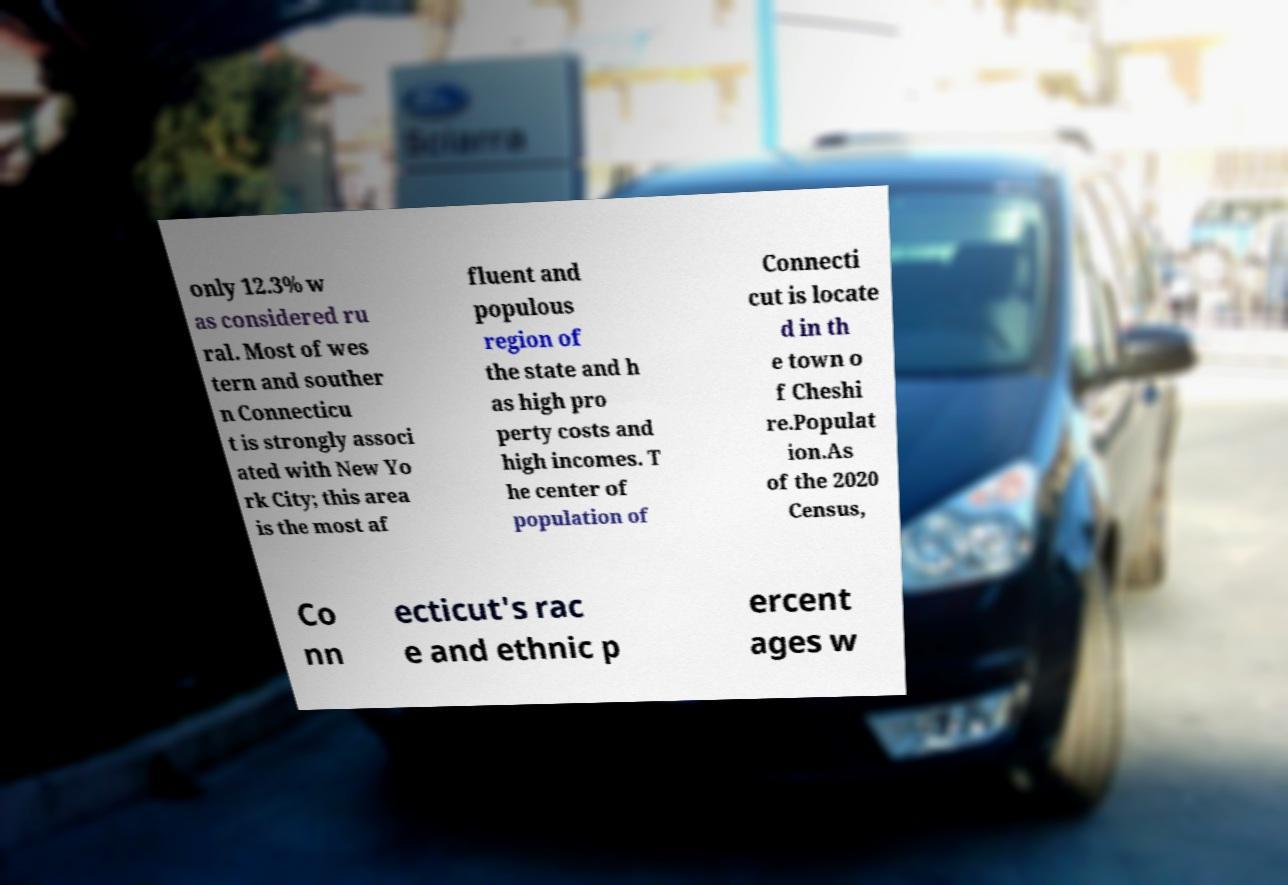Can you accurately transcribe the text from the provided image for me? only 12.3% w as considered ru ral. Most of wes tern and souther n Connecticu t is strongly associ ated with New Yo rk City; this area is the most af fluent and populous region of the state and h as high pro perty costs and high incomes. T he center of population of Connecti cut is locate d in th e town o f Cheshi re.Populat ion.As of the 2020 Census, Co nn ecticut's rac e and ethnic p ercent ages w 